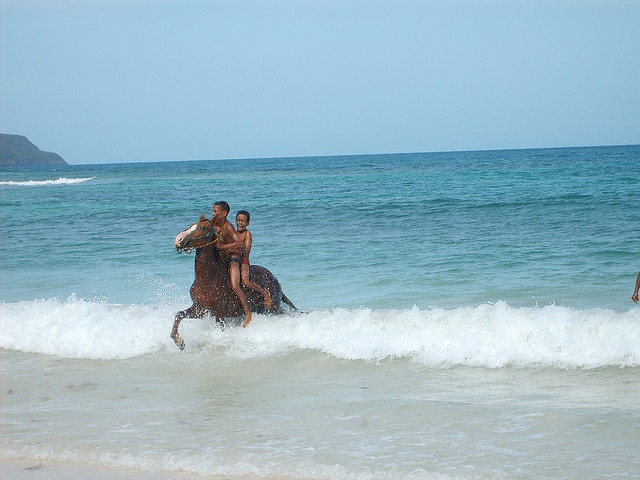Describe the objects in this image and their specific colors. I can see horse in lightblue, black, gray, maroon, and darkgray tones, people in lightblue, brown, maroon, and black tones, people in lightblue, brown, maroon, and black tones, and people in lightblue, gray, brown, and maroon tones in this image. 